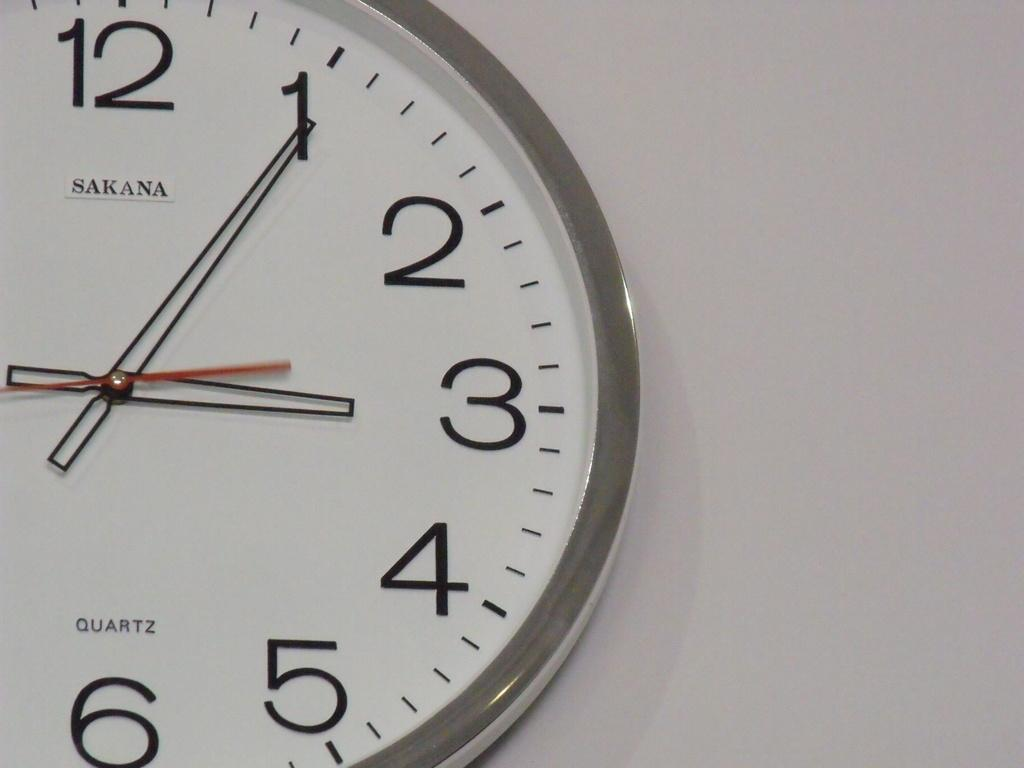<image>
Summarize the visual content of the image. A Sakana Quartz clock is hanging on a white wall. 